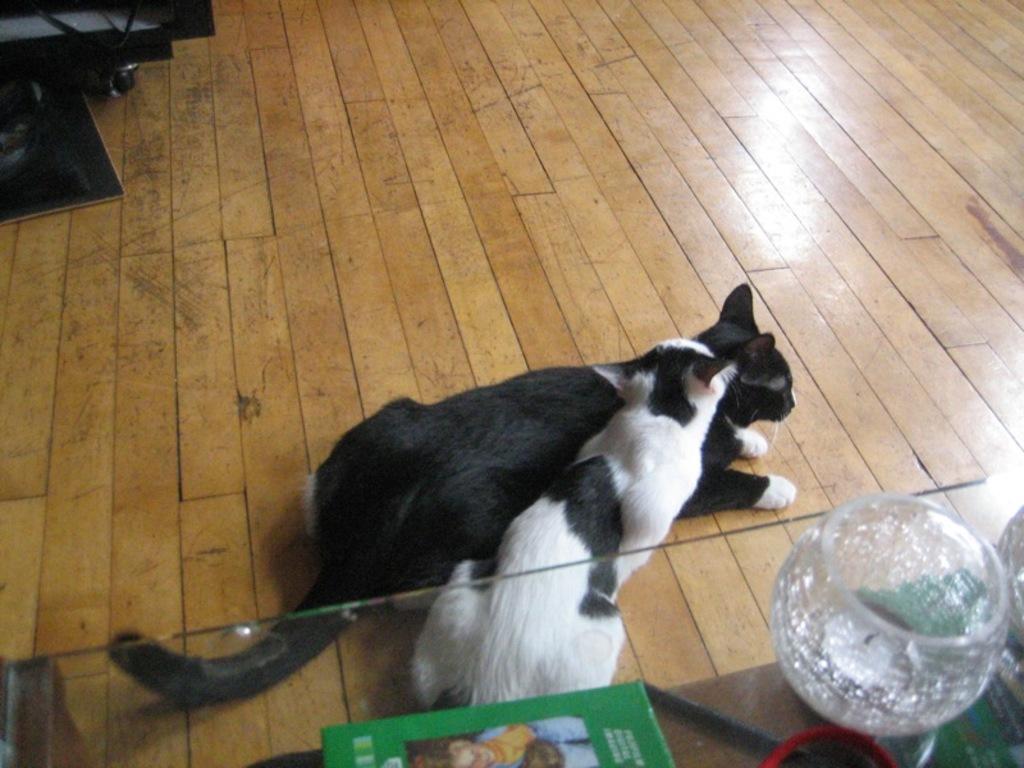Could you give a brief overview of what you see in this image? There are two cats on the wooden floor as we can see in the middle of this image. There is one glass and a book kept on a glass table at the bottom of this image. There is a black color object kept on the floor as we can see at the top left corner of this image. 